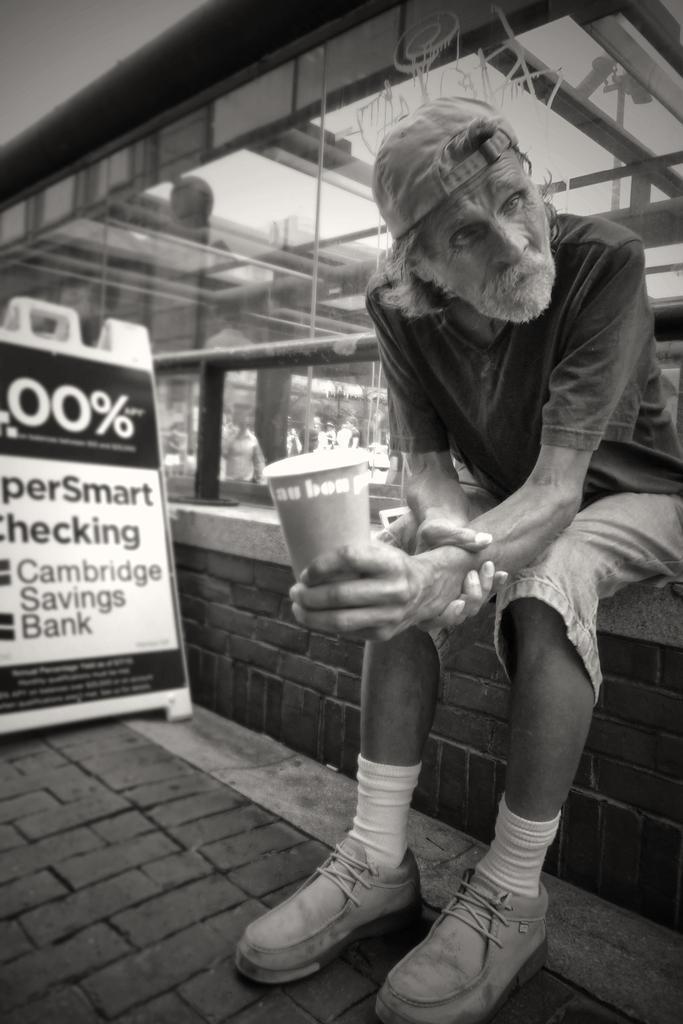Could you give a brief overview of what you see in this image? This is a black and white pic. On the right a man is sitting on a platform by holding a cup in his hand and on the left we can see a hoarding on the ground. In the background we can see glass doors and wall. Through glass doors we can see few persons and poles. 